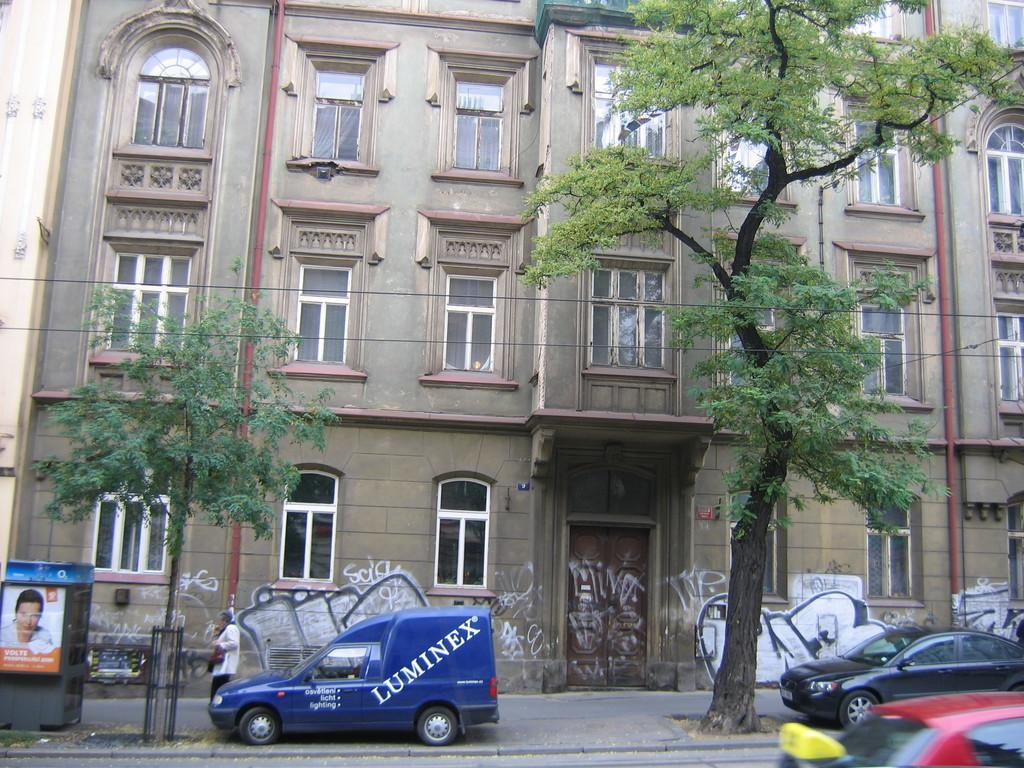Provide a one-sentence caption for the provided image. an outside of a building with a blue van outside of it that says 'luminex'. 